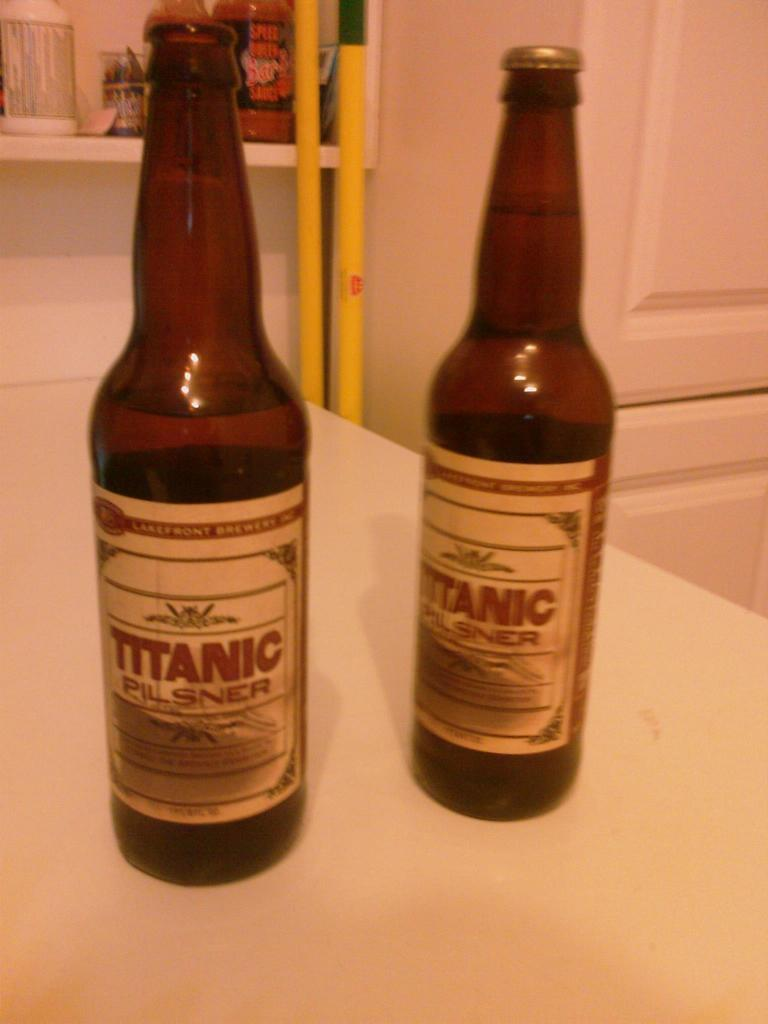<image>
Share a concise interpretation of the image provided. Two cans of beer side by side both saying "TITANIC". 